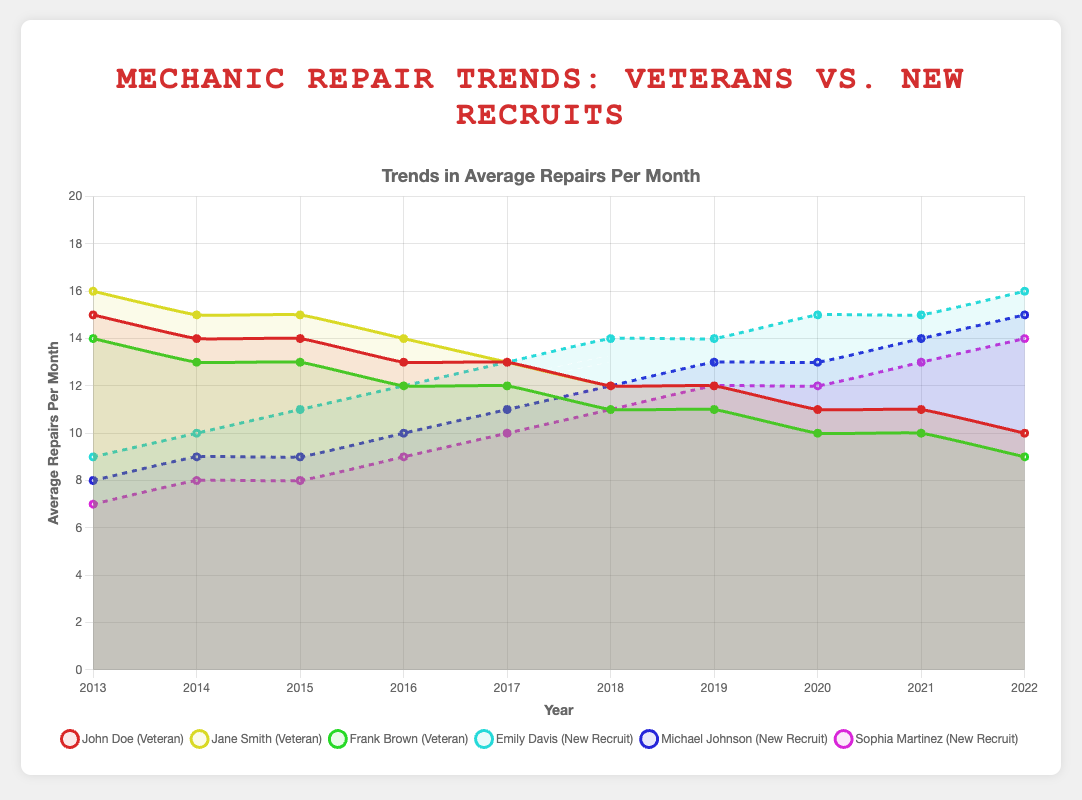What's the average number of repairs made per month by veteran mechanics in 2013? To find the average, sum the monthly repairs for John Doe, Jane Smith, and Frank Brown in 2013 and divide by 3. (15 + 16 + 14) = 45; 45 / 3 = 15
Answer: 15 Which new recruit showed the greatest increase in repairs from 2013 to 2022? Compare the number of repairs in 2013 and 2022 for each recruit. Emily Davis: 9 to 16, increase of 7; Michael Johnson: 8 to 15, increase of 7; Sophia Martinez: 7 to 14, increase of 7. All recruits have the same increase.
Answer: All equally Who had the highest number of repairs in 2019? From the plot, identify the highest value among all the mechanics in 2019. For veterans: John Doe (12), Jane Smith (12), Frank Brown (11). For new recruits: Emily Davis (14), Michael Johnson (13), Sophia Martinez (12). Emily Davis has the highest with 14 repairs.
Answer: Emily Davis What's the difference in the number of repairs between Jane Smith and Michael Johnson in 2020? Find the repairs done by Jane Smith and Michael Johnson in 2020 and calculate the difference. Jane Smith: 11, Michael Johnson: 13; 13 - 11 = 2
Answer: 2 How did the average repairs per month for veteran mechanics change from 2013 to 2022? Calculate the average repairs for veterans in 2013 and 2022. In 2013: (15 + 16 + 14) / 3 = 15, in 2022: (10 + 10 + 9) / 3 ≈ 9.67. The change is 15 - 9.67 ≈ 5.33
Answer: Decreased by approximately 5.33 Which new recruit consistently increased their number of repairs each year? Compare the yearly repair data for each new recruit to identify a consistent increase. Only Emily Davis and Michael Johnson increased repairs every year. Sophia Martinez did the same.
Answer: Emily Davis, Michael Johnson, and Sophia Martinez Which veteran mechanic had the steadiest decline in average repairs per month from 2013 to 2022? Check the decrease in the number of repairs each veteran had over the years. All veterans show a steady decline, but Jane Smith's numbers are distinctly linear as they decrease by 1 repair each couple of years.
Answer: Jane Smith What is the average number of repairs done by all mechanics in 2018? Sum the repairs done by all veteran mechanics and new recruits in 2018 and divide by the total number of mechanics. Veterans: 12 + 12 + 11 = 35; New recruits: 14 + 12 + 11 = 37; Total = 35 + 37 = 72; Average = 72 / 6 = 12
Answer: 12 How many more repairs did Emily Davis make in 2022 compared to Frank Brown? Find the repairs done by Emily Davis and Frank Brown in 2022 and calculate the difference. Emily Davis: 16, Frank Brown: 9; 16 - 9 = 7
Answer: 7 Was there a year when any new recruit outperformed any veteran mechanic? Compare the yearly performance of new recruits and veterans. In 2017, Emily Davis (13) and John Doe (13) are equal. From 2018 onwards, Emily Davis outperformed John Doe.
Answer: Yes, from 2018 